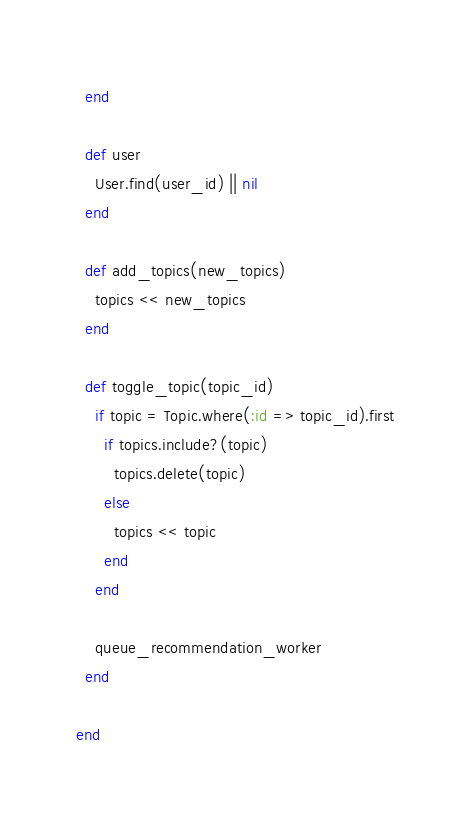Convert code to text. <code><loc_0><loc_0><loc_500><loc_500><_Ruby_>  end

  def user
    User.find(user_id) || nil
  end

  def add_topics(new_topics)
    topics << new_topics
  end

  def toggle_topic(topic_id)
    if topic = Topic.where(:id => topic_id).first
      if topics.include?(topic)
        topics.delete(topic)
      else
        topics << topic
      end
    end

    queue_recommendation_worker
  end

end
</code> 